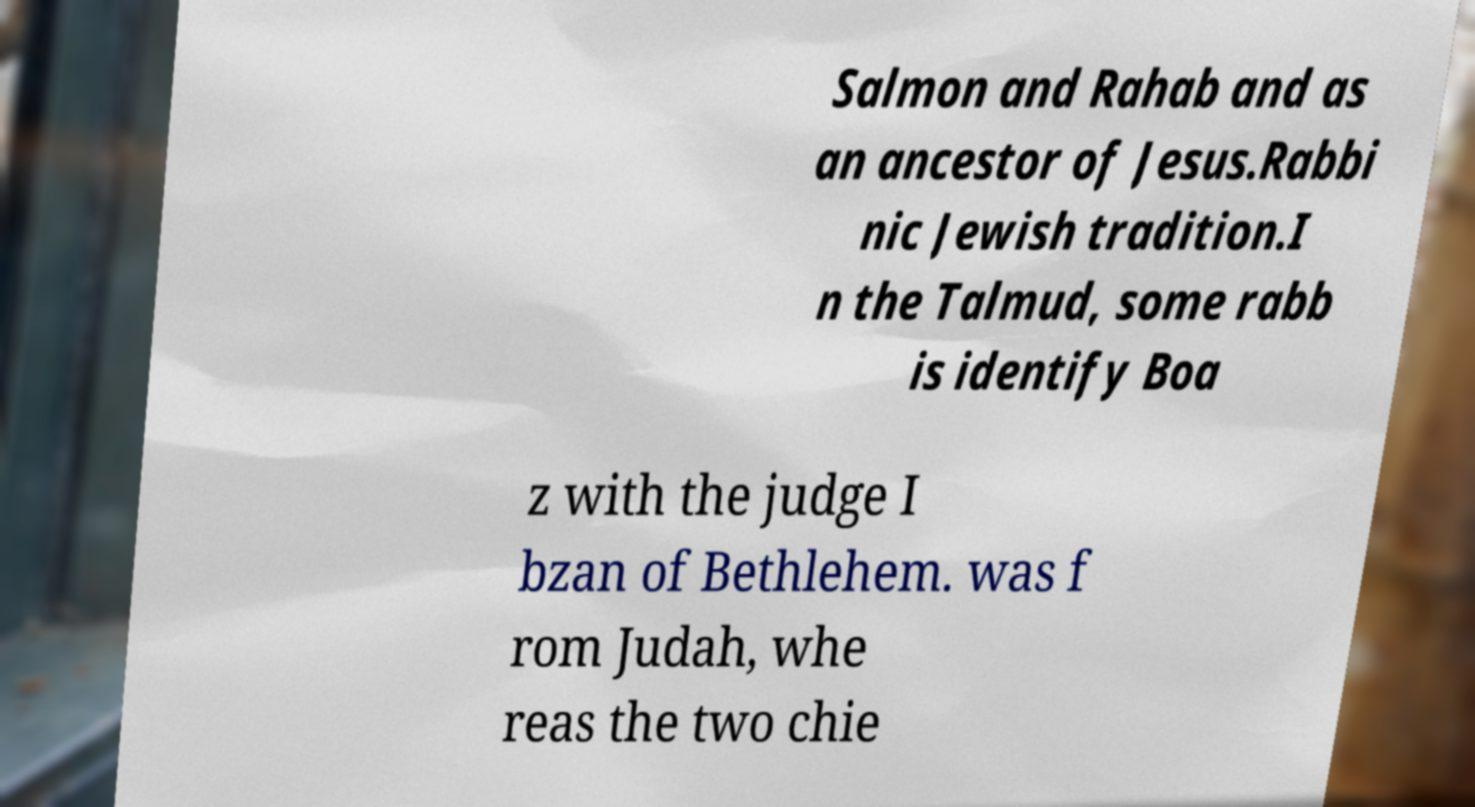Could you extract and type out the text from this image? Salmon and Rahab and as an ancestor of Jesus.Rabbi nic Jewish tradition.I n the Talmud, some rabb is identify Boa z with the judge I bzan of Bethlehem. was f rom Judah, whe reas the two chie 